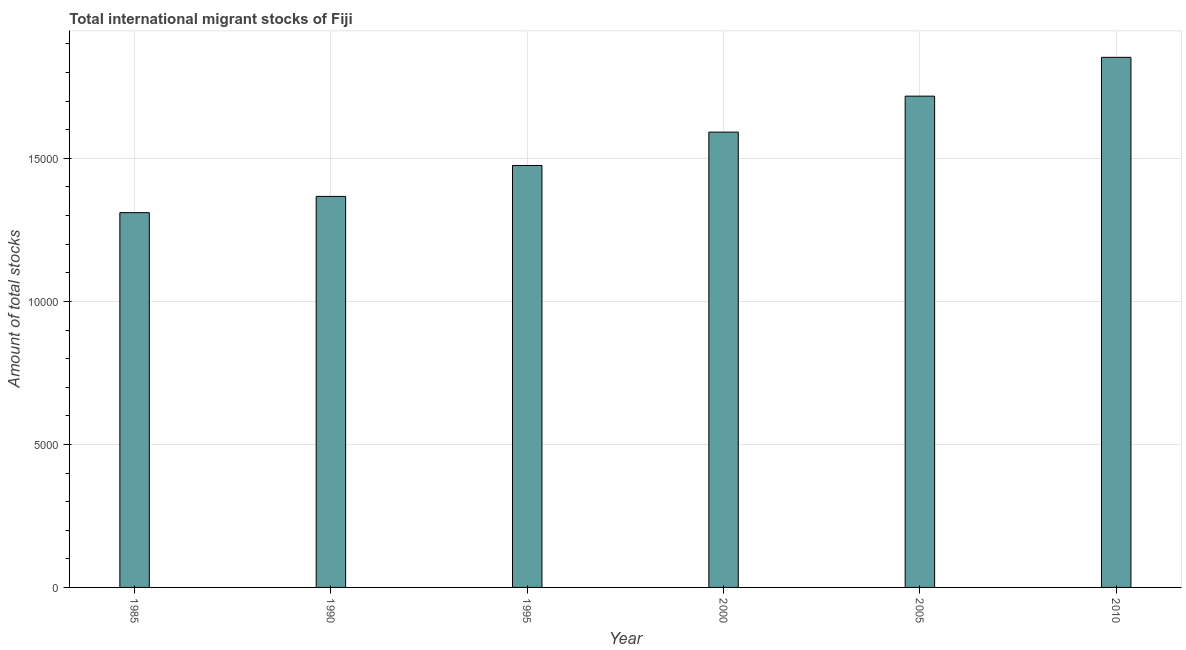Does the graph contain any zero values?
Offer a terse response. No. Does the graph contain grids?
Provide a short and direct response. Yes. What is the title of the graph?
Ensure brevity in your answer.  Total international migrant stocks of Fiji. What is the label or title of the X-axis?
Ensure brevity in your answer.  Year. What is the label or title of the Y-axis?
Offer a very short reply. Amount of total stocks. What is the total number of international migrant stock in 1995?
Your response must be concise. 1.48e+04. Across all years, what is the maximum total number of international migrant stock?
Your response must be concise. 1.85e+04. Across all years, what is the minimum total number of international migrant stock?
Ensure brevity in your answer.  1.31e+04. What is the sum of the total number of international migrant stock?
Provide a short and direct response. 9.32e+04. What is the difference between the total number of international migrant stock in 2005 and 2010?
Ensure brevity in your answer.  -1357. What is the average total number of international migrant stock per year?
Offer a very short reply. 1.55e+04. What is the median total number of international migrant stock?
Provide a succinct answer. 1.53e+04. What is the ratio of the total number of international migrant stock in 2000 to that in 2005?
Keep it short and to the point. 0.93. Is the difference between the total number of international migrant stock in 1995 and 2000 greater than the difference between any two years?
Your answer should be very brief. No. What is the difference between the highest and the second highest total number of international migrant stock?
Keep it short and to the point. 1357. Is the sum of the total number of international migrant stock in 1990 and 1995 greater than the maximum total number of international migrant stock across all years?
Your response must be concise. Yes. What is the difference between the highest and the lowest total number of international migrant stock?
Offer a terse response. 5430. How many bars are there?
Give a very brief answer. 6. What is the Amount of total stocks in 1985?
Provide a short and direct response. 1.31e+04. What is the Amount of total stocks in 1990?
Keep it short and to the point. 1.37e+04. What is the Amount of total stocks in 1995?
Offer a terse response. 1.48e+04. What is the Amount of total stocks of 2000?
Make the answer very short. 1.59e+04. What is the Amount of total stocks of 2005?
Offer a very short reply. 1.72e+04. What is the Amount of total stocks in 2010?
Your answer should be very brief. 1.85e+04. What is the difference between the Amount of total stocks in 1985 and 1990?
Provide a short and direct response. -568. What is the difference between the Amount of total stocks in 1985 and 1995?
Your answer should be compact. -1649. What is the difference between the Amount of total stocks in 1985 and 2000?
Ensure brevity in your answer.  -2815. What is the difference between the Amount of total stocks in 1985 and 2005?
Your answer should be compact. -4073. What is the difference between the Amount of total stocks in 1985 and 2010?
Make the answer very short. -5430. What is the difference between the Amount of total stocks in 1990 and 1995?
Make the answer very short. -1081. What is the difference between the Amount of total stocks in 1990 and 2000?
Offer a very short reply. -2247. What is the difference between the Amount of total stocks in 1990 and 2005?
Make the answer very short. -3505. What is the difference between the Amount of total stocks in 1990 and 2010?
Provide a short and direct response. -4862. What is the difference between the Amount of total stocks in 1995 and 2000?
Keep it short and to the point. -1166. What is the difference between the Amount of total stocks in 1995 and 2005?
Give a very brief answer. -2424. What is the difference between the Amount of total stocks in 1995 and 2010?
Ensure brevity in your answer.  -3781. What is the difference between the Amount of total stocks in 2000 and 2005?
Your answer should be very brief. -1258. What is the difference between the Amount of total stocks in 2000 and 2010?
Make the answer very short. -2615. What is the difference between the Amount of total stocks in 2005 and 2010?
Give a very brief answer. -1357. What is the ratio of the Amount of total stocks in 1985 to that in 1990?
Your response must be concise. 0.96. What is the ratio of the Amount of total stocks in 1985 to that in 1995?
Make the answer very short. 0.89. What is the ratio of the Amount of total stocks in 1985 to that in 2000?
Provide a short and direct response. 0.82. What is the ratio of the Amount of total stocks in 1985 to that in 2005?
Your response must be concise. 0.76. What is the ratio of the Amount of total stocks in 1985 to that in 2010?
Provide a short and direct response. 0.71. What is the ratio of the Amount of total stocks in 1990 to that in 1995?
Offer a terse response. 0.93. What is the ratio of the Amount of total stocks in 1990 to that in 2000?
Give a very brief answer. 0.86. What is the ratio of the Amount of total stocks in 1990 to that in 2005?
Your response must be concise. 0.8. What is the ratio of the Amount of total stocks in 1990 to that in 2010?
Offer a terse response. 0.74. What is the ratio of the Amount of total stocks in 1995 to that in 2000?
Your answer should be compact. 0.93. What is the ratio of the Amount of total stocks in 1995 to that in 2005?
Your answer should be compact. 0.86. What is the ratio of the Amount of total stocks in 1995 to that in 2010?
Your answer should be very brief. 0.8. What is the ratio of the Amount of total stocks in 2000 to that in 2005?
Keep it short and to the point. 0.93. What is the ratio of the Amount of total stocks in 2000 to that in 2010?
Ensure brevity in your answer.  0.86. What is the ratio of the Amount of total stocks in 2005 to that in 2010?
Your response must be concise. 0.93. 